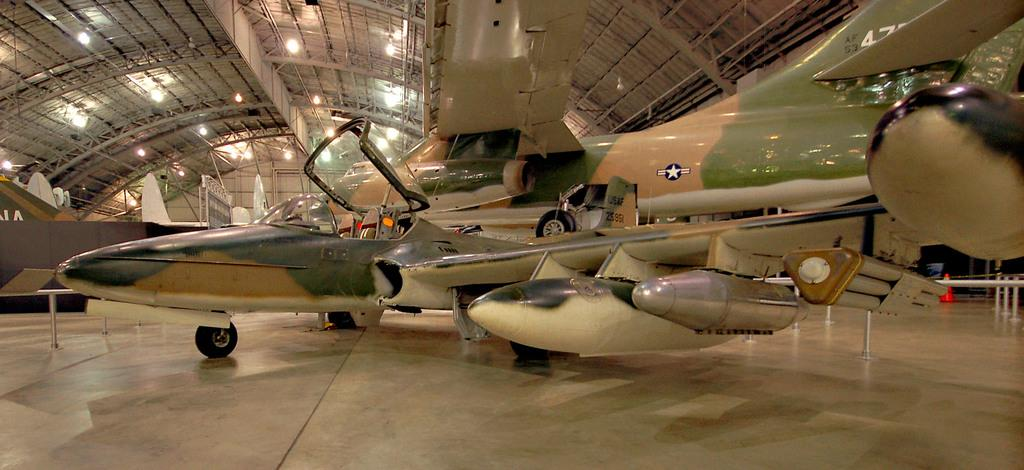What is the main subject of the image? The main subject of the image is an aeroplane. Where is the aeroplane located in the image? The aeroplane is in a hanger. What type of vein can be seen in the image? There is no vein present in the image; it features an aeroplane in a hanger. What part of the aeroplane is made of flesh? Aeroplanes are not made of flesh; they are typically made of metal or composite materials. 